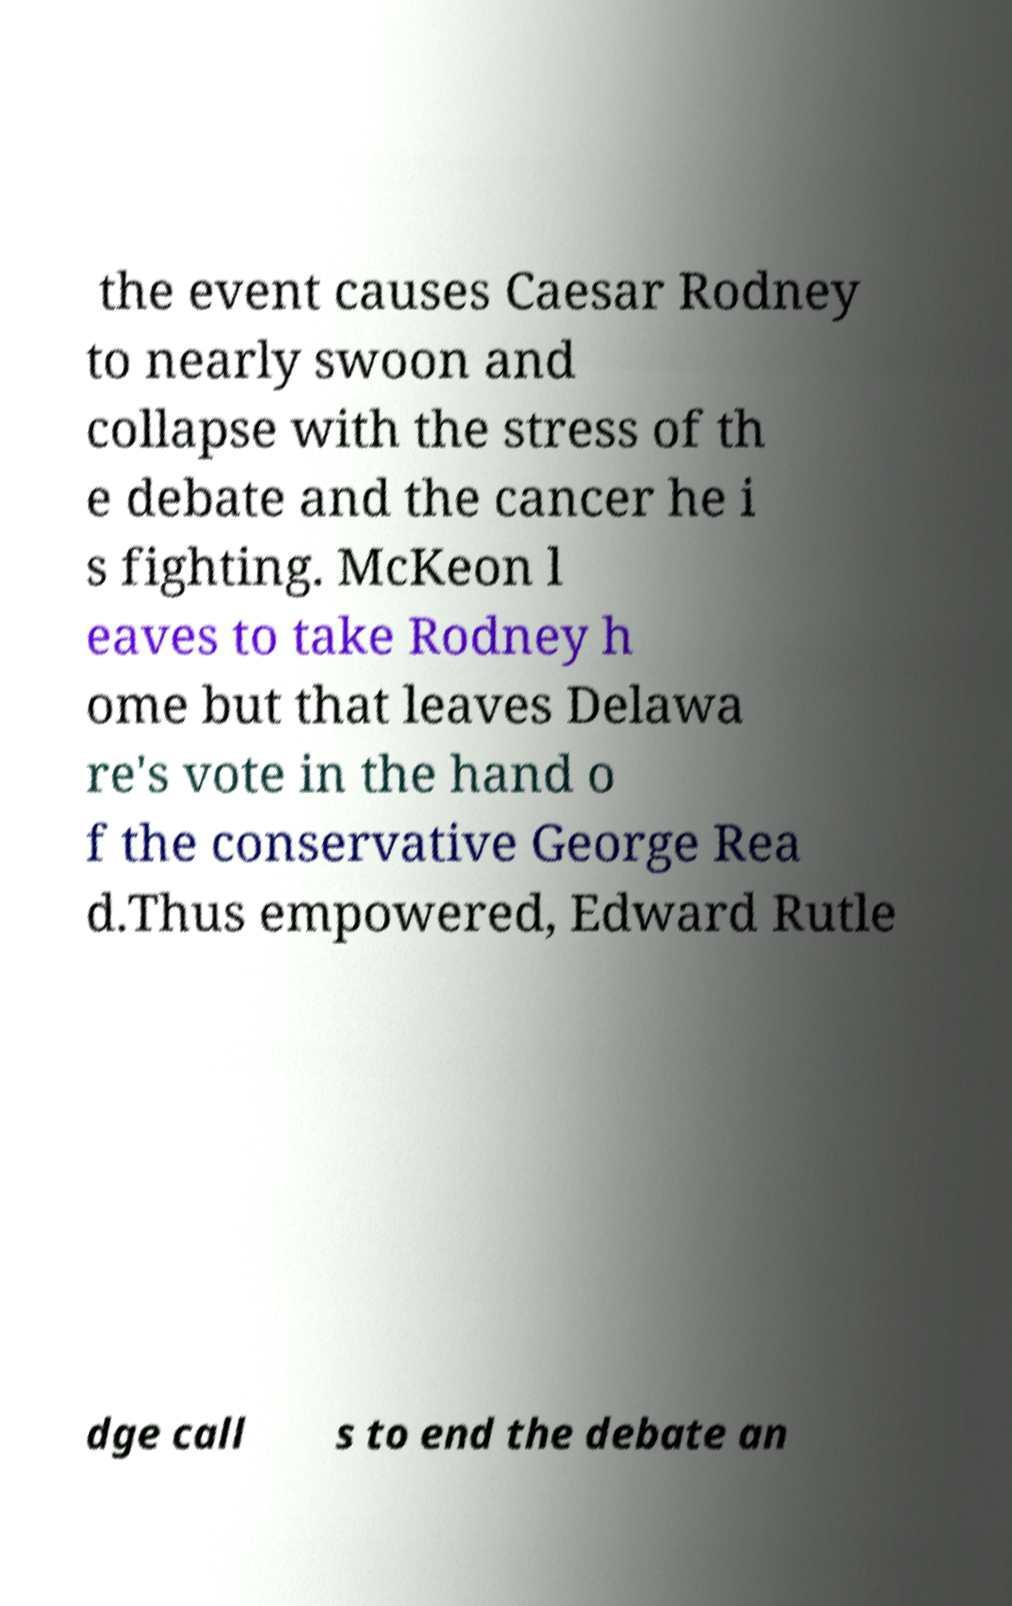I need the written content from this picture converted into text. Can you do that? the event causes Caesar Rodney to nearly swoon and collapse with the stress of th e debate and the cancer he i s fighting. McKeon l eaves to take Rodney h ome but that leaves Delawa re's vote in the hand o f the conservative George Rea d.Thus empowered, Edward Rutle dge call s to end the debate an 